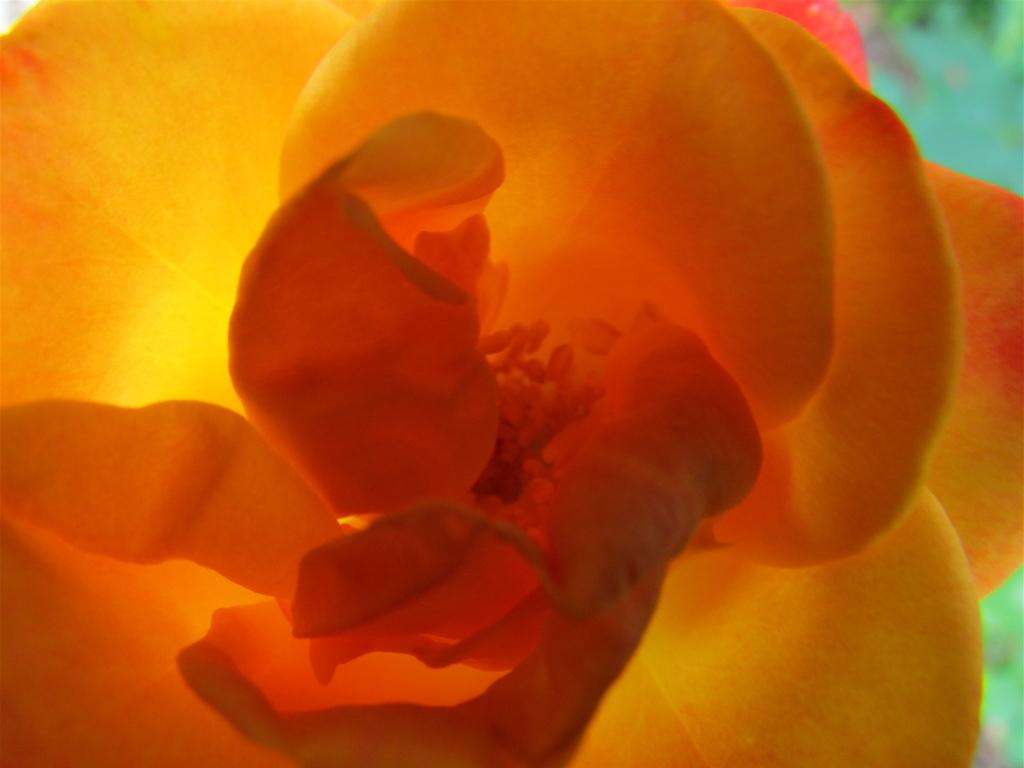What color are the objects in the image? The objects in the image are orange-colored. What color is the background of the image? The background of the image has a green color. How is the image's focus distributed? The image is slightly blurry in the background. What type of heat can be felt coming from the orange-colored objects in the image? There is no indication of heat or temperature in the image, as it only shows the color of the objects. 